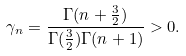<formula> <loc_0><loc_0><loc_500><loc_500>\gamma _ { n } = \frac { \Gamma ( n + \frac { 3 } { 2 } ) } { \Gamma ( \frac { 3 } { 2 } ) \Gamma ( n + 1 ) } > 0 .</formula> 